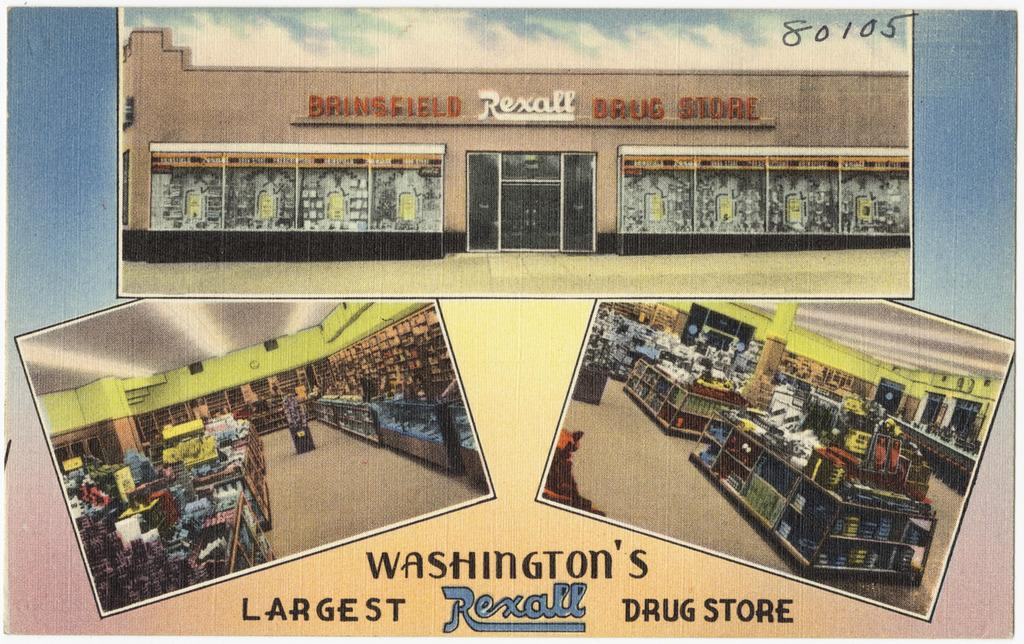<image>
Write a terse but informative summary of the picture. bringfield rexall drug store looks like a postcard 